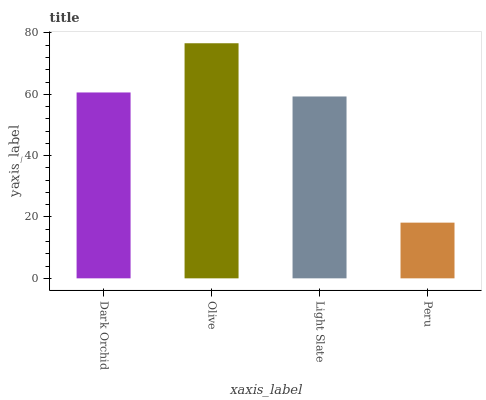Is Peru the minimum?
Answer yes or no. Yes. Is Olive the maximum?
Answer yes or no. Yes. Is Light Slate the minimum?
Answer yes or no. No. Is Light Slate the maximum?
Answer yes or no. No. Is Olive greater than Light Slate?
Answer yes or no. Yes. Is Light Slate less than Olive?
Answer yes or no. Yes. Is Light Slate greater than Olive?
Answer yes or no. No. Is Olive less than Light Slate?
Answer yes or no. No. Is Dark Orchid the high median?
Answer yes or no. Yes. Is Light Slate the low median?
Answer yes or no. Yes. Is Olive the high median?
Answer yes or no. No. Is Dark Orchid the low median?
Answer yes or no. No. 